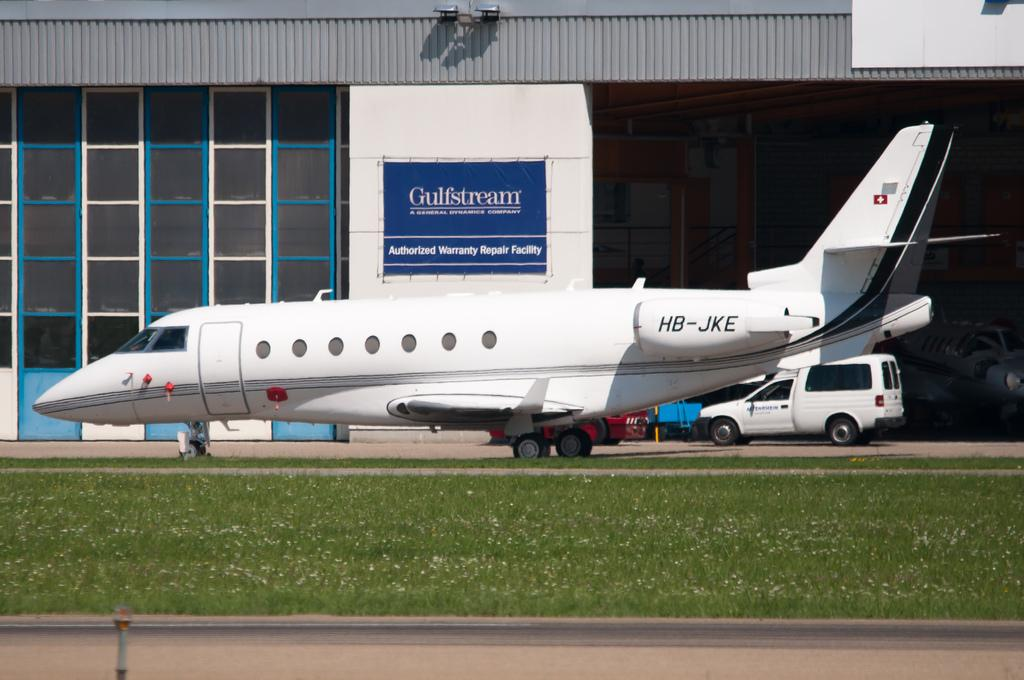What is the main subject of the image? The main subject of the image is a plane. What is the plane's current state in the image? The plane has wheels on the ground. What is the landscape like in the image? The land is covered with grass. What else can be seen on the wall in the image? There is a banner on a wall. What other types of transportation are visible in the image? Vehicles are visible in the image. Can you see any monkeys swimming in the image? There are no monkeys or swimming activities depicted in the image. 